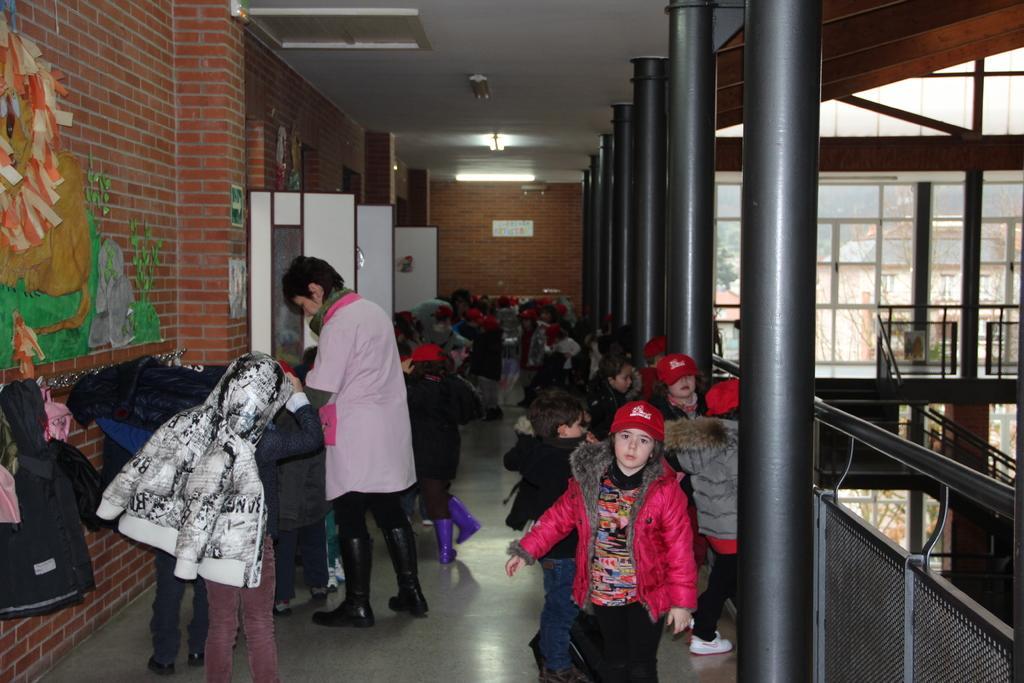Could you give a brief overview of what you see in this image? In this image there are group of children standing on the balcony along with one person, on the left side there is a wall with painting and also there are hangers with jackets and lights in the roof. 